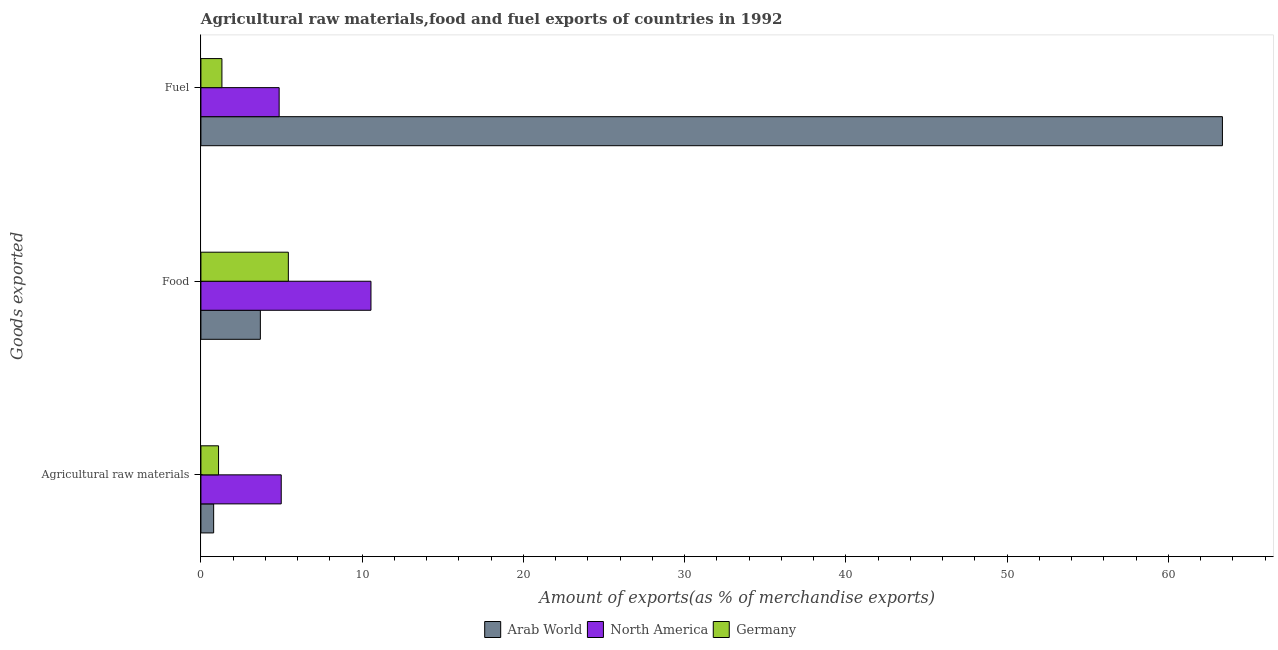How many groups of bars are there?
Ensure brevity in your answer.  3. Are the number of bars per tick equal to the number of legend labels?
Your response must be concise. Yes. How many bars are there on the 1st tick from the top?
Provide a succinct answer. 3. What is the label of the 2nd group of bars from the top?
Ensure brevity in your answer.  Food. What is the percentage of fuel exports in Arab World?
Offer a terse response. 63.35. Across all countries, what is the maximum percentage of fuel exports?
Offer a very short reply. 63.35. Across all countries, what is the minimum percentage of fuel exports?
Make the answer very short. 1.3. In which country was the percentage of fuel exports maximum?
Provide a succinct answer. Arab World. In which country was the percentage of food exports minimum?
Offer a very short reply. Arab World. What is the total percentage of food exports in the graph?
Your answer should be very brief. 19.65. What is the difference between the percentage of raw materials exports in North America and that in Germany?
Keep it short and to the point. 3.89. What is the difference between the percentage of fuel exports in Arab World and the percentage of raw materials exports in Germany?
Give a very brief answer. 62.25. What is the average percentage of fuel exports per country?
Your answer should be very brief. 23.17. What is the difference between the percentage of raw materials exports and percentage of food exports in North America?
Your answer should be compact. -5.56. What is the ratio of the percentage of food exports in Germany to that in Arab World?
Ensure brevity in your answer.  1.47. Is the difference between the percentage of raw materials exports in North America and Arab World greater than the difference between the percentage of food exports in North America and Arab World?
Your answer should be very brief. No. What is the difference between the highest and the second highest percentage of food exports?
Offer a terse response. 5.12. What is the difference between the highest and the lowest percentage of raw materials exports?
Keep it short and to the point. 4.19. Is it the case that in every country, the sum of the percentage of raw materials exports and percentage of food exports is greater than the percentage of fuel exports?
Your answer should be compact. No. Are all the bars in the graph horizontal?
Your answer should be very brief. Yes. Where does the legend appear in the graph?
Ensure brevity in your answer.  Bottom center. What is the title of the graph?
Your response must be concise. Agricultural raw materials,food and fuel exports of countries in 1992. What is the label or title of the X-axis?
Offer a very short reply. Amount of exports(as % of merchandise exports). What is the label or title of the Y-axis?
Provide a succinct answer. Goods exported. What is the Amount of exports(as % of merchandise exports) of Arab World in Agricultural raw materials?
Ensure brevity in your answer.  0.79. What is the Amount of exports(as % of merchandise exports) of North America in Agricultural raw materials?
Your answer should be very brief. 4.98. What is the Amount of exports(as % of merchandise exports) in Germany in Agricultural raw materials?
Your response must be concise. 1.09. What is the Amount of exports(as % of merchandise exports) in Arab World in Food?
Provide a short and direct response. 3.69. What is the Amount of exports(as % of merchandise exports) in North America in Food?
Provide a short and direct response. 10.55. What is the Amount of exports(as % of merchandise exports) of Germany in Food?
Make the answer very short. 5.42. What is the Amount of exports(as % of merchandise exports) in Arab World in Fuel?
Provide a short and direct response. 63.35. What is the Amount of exports(as % of merchandise exports) of North America in Fuel?
Your response must be concise. 4.85. What is the Amount of exports(as % of merchandise exports) of Germany in Fuel?
Make the answer very short. 1.3. Across all Goods exported, what is the maximum Amount of exports(as % of merchandise exports) in Arab World?
Offer a terse response. 63.35. Across all Goods exported, what is the maximum Amount of exports(as % of merchandise exports) in North America?
Provide a short and direct response. 10.55. Across all Goods exported, what is the maximum Amount of exports(as % of merchandise exports) in Germany?
Keep it short and to the point. 5.42. Across all Goods exported, what is the minimum Amount of exports(as % of merchandise exports) in Arab World?
Keep it short and to the point. 0.79. Across all Goods exported, what is the minimum Amount of exports(as % of merchandise exports) in North America?
Your answer should be very brief. 4.85. Across all Goods exported, what is the minimum Amount of exports(as % of merchandise exports) of Germany?
Provide a succinct answer. 1.09. What is the total Amount of exports(as % of merchandise exports) in Arab World in the graph?
Offer a very short reply. 67.82. What is the total Amount of exports(as % of merchandise exports) of North America in the graph?
Ensure brevity in your answer.  20.38. What is the total Amount of exports(as % of merchandise exports) in Germany in the graph?
Your answer should be compact. 7.82. What is the difference between the Amount of exports(as % of merchandise exports) in Arab World in Agricultural raw materials and that in Food?
Provide a succinct answer. -2.9. What is the difference between the Amount of exports(as % of merchandise exports) in North America in Agricultural raw materials and that in Food?
Make the answer very short. -5.56. What is the difference between the Amount of exports(as % of merchandise exports) in Germany in Agricultural raw materials and that in Food?
Give a very brief answer. -4.33. What is the difference between the Amount of exports(as % of merchandise exports) of Arab World in Agricultural raw materials and that in Fuel?
Provide a succinct answer. -62.56. What is the difference between the Amount of exports(as % of merchandise exports) in North America in Agricultural raw materials and that in Fuel?
Your answer should be compact. 0.13. What is the difference between the Amount of exports(as % of merchandise exports) of Germany in Agricultural raw materials and that in Fuel?
Provide a succinct answer. -0.21. What is the difference between the Amount of exports(as % of merchandise exports) in Arab World in Food and that in Fuel?
Provide a succinct answer. -59.66. What is the difference between the Amount of exports(as % of merchandise exports) of North America in Food and that in Fuel?
Your answer should be very brief. 5.69. What is the difference between the Amount of exports(as % of merchandise exports) of Germany in Food and that in Fuel?
Provide a short and direct response. 4.12. What is the difference between the Amount of exports(as % of merchandise exports) in Arab World in Agricultural raw materials and the Amount of exports(as % of merchandise exports) in North America in Food?
Offer a terse response. -9.76. What is the difference between the Amount of exports(as % of merchandise exports) of Arab World in Agricultural raw materials and the Amount of exports(as % of merchandise exports) of Germany in Food?
Offer a very short reply. -4.63. What is the difference between the Amount of exports(as % of merchandise exports) of North America in Agricultural raw materials and the Amount of exports(as % of merchandise exports) of Germany in Food?
Ensure brevity in your answer.  -0.44. What is the difference between the Amount of exports(as % of merchandise exports) of Arab World in Agricultural raw materials and the Amount of exports(as % of merchandise exports) of North America in Fuel?
Your answer should be compact. -4.06. What is the difference between the Amount of exports(as % of merchandise exports) of Arab World in Agricultural raw materials and the Amount of exports(as % of merchandise exports) of Germany in Fuel?
Ensure brevity in your answer.  -0.51. What is the difference between the Amount of exports(as % of merchandise exports) of North America in Agricultural raw materials and the Amount of exports(as % of merchandise exports) of Germany in Fuel?
Keep it short and to the point. 3.68. What is the difference between the Amount of exports(as % of merchandise exports) in Arab World in Food and the Amount of exports(as % of merchandise exports) in North America in Fuel?
Keep it short and to the point. -1.17. What is the difference between the Amount of exports(as % of merchandise exports) in Arab World in Food and the Amount of exports(as % of merchandise exports) in Germany in Fuel?
Your response must be concise. 2.38. What is the difference between the Amount of exports(as % of merchandise exports) in North America in Food and the Amount of exports(as % of merchandise exports) in Germany in Fuel?
Provide a short and direct response. 9.24. What is the average Amount of exports(as % of merchandise exports) of Arab World per Goods exported?
Your answer should be compact. 22.61. What is the average Amount of exports(as % of merchandise exports) in North America per Goods exported?
Provide a succinct answer. 6.79. What is the average Amount of exports(as % of merchandise exports) in Germany per Goods exported?
Give a very brief answer. 2.61. What is the difference between the Amount of exports(as % of merchandise exports) in Arab World and Amount of exports(as % of merchandise exports) in North America in Agricultural raw materials?
Your response must be concise. -4.19. What is the difference between the Amount of exports(as % of merchandise exports) in Arab World and Amount of exports(as % of merchandise exports) in Germany in Agricultural raw materials?
Keep it short and to the point. -0.3. What is the difference between the Amount of exports(as % of merchandise exports) in North America and Amount of exports(as % of merchandise exports) in Germany in Agricultural raw materials?
Offer a very short reply. 3.89. What is the difference between the Amount of exports(as % of merchandise exports) in Arab World and Amount of exports(as % of merchandise exports) in North America in Food?
Keep it short and to the point. -6.86. What is the difference between the Amount of exports(as % of merchandise exports) of Arab World and Amount of exports(as % of merchandise exports) of Germany in Food?
Your response must be concise. -1.74. What is the difference between the Amount of exports(as % of merchandise exports) of North America and Amount of exports(as % of merchandise exports) of Germany in Food?
Offer a very short reply. 5.12. What is the difference between the Amount of exports(as % of merchandise exports) in Arab World and Amount of exports(as % of merchandise exports) in North America in Fuel?
Offer a very short reply. 58.49. What is the difference between the Amount of exports(as % of merchandise exports) of Arab World and Amount of exports(as % of merchandise exports) of Germany in Fuel?
Provide a short and direct response. 62.04. What is the difference between the Amount of exports(as % of merchandise exports) of North America and Amount of exports(as % of merchandise exports) of Germany in Fuel?
Your answer should be compact. 3.55. What is the ratio of the Amount of exports(as % of merchandise exports) of Arab World in Agricultural raw materials to that in Food?
Offer a very short reply. 0.21. What is the ratio of the Amount of exports(as % of merchandise exports) of North America in Agricultural raw materials to that in Food?
Keep it short and to the point. 0.47. What is the ratio of the Amount of exports(as % of merchandise exports) in Germany in Agricultural raw materials to that in Food?
Offer a very short reply. 0.2. What is the ratio of the Amount of exports(as % of merchandise exports) of Arab World in Agricultural raw materials to that in Fuel?
Provide a succinct answer. 0.01. What is the ratio of the Amount of exports(as % of merchandise exports) of North America in Agricultural raw materials to that in Fuel?
Provide a short and direct response. 1.03. What is the ratio of the Amount of exports(as % of merchandise exports) of Germany in Agricultural raw materials to that in Fuel?
Your answer should be compact. 0.84. What is the ratio of the Amount of exports(as % of merchandise exports) in Arab World in Food to that in Fuel?
Your answer should be compact. 0.06. What is the ratio of the Amount of exports(as % of merchandise exports) of North America in Food to that in Fuel?
Your response must be concise. 2.17. What is the ratio of the Amount of exports(as % of merchandise exports) in Germany in Food to that in Fuel?
Provide a succinct answer. 4.16. What is the difference between the highest and the second highest Amount of exports(as % of merchandise exports) in Arab World?
Make the answer very short. 59.66. What is the difference between the highest and the second highest Amount of exports(as % of merchandise exports) of North America?
Provide a short and direct response. 5.56. What is the difference between the highest and the second highest Amount of exports(as % of merchandise exports) of Germany?
Give a very brief answer. 4.12. What is the difference between the highest and the lowest Amount of exports(as % of merchandise exports) in Arab World?
Provide a short and direct response. 62.56. What is the difference between the highest and the lowest Amount of exports(as % of merchandise exports) in North America?
Offer a very short reply. 5.69. What is the difference between the highest and the lowest Amount of exports(as % of merchandise exports) of Germany?
Keep it short and to the point. 4.33. 